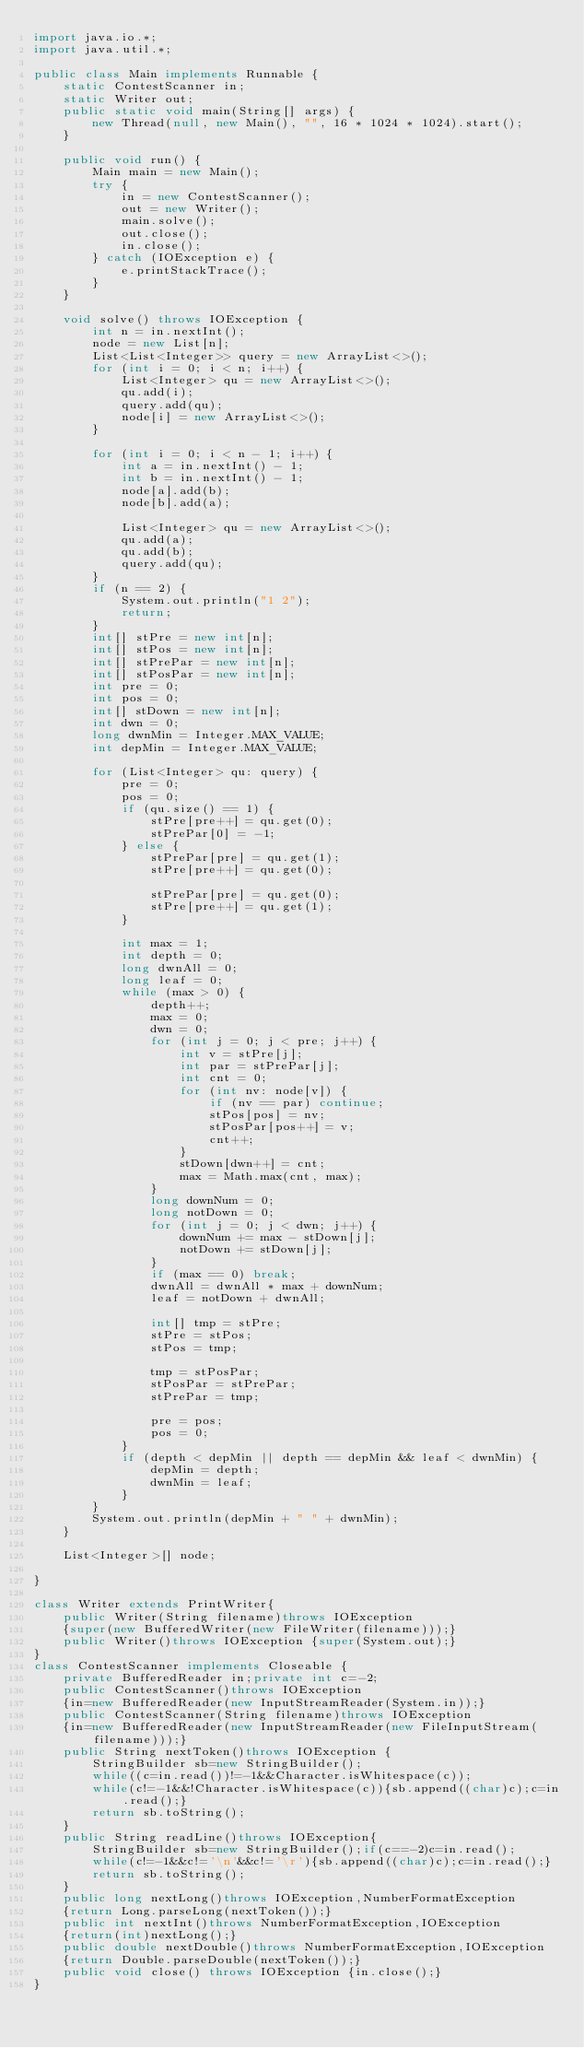Convert code to text. <code><loc_0><loc_0><loc_500><loc_500><_Java_>import java.io.*;
import java.util.*;

public class Main implements Runnable {
    static ContestScanner in;
    static Writer out;
    public static void main(String[] args) {
        new Thread(null, new Main(), "", 16 * 1024 * 1024).start();
    }

    public void run() {
        Main main = new Main();
        try {
            in = new ContestScanner();
            out = new Writer();
            main.solve();
            out.close();
            in.close();
        } catch (IOException e) {
            e.printStackTrace();
        }
    }

    void solve() throws IOException {
        int n = in.nextInt();
        node = new List[n];
        List<List<Integer>> query = new ArrayList<>();
        for (int i = 0; i < n; i++) {
            List<Integer> qu = new ArrayList<>();
            qu.add(i);
            query.add(qu);
            node[i] = new ArrayList<>();
        }

        for (int i = 0; i < n - 1; i++) {
            int a = in.nextInt() - 1;
            int b = in.nextInt() - 1;
            node[a].add(b);
            node[b].add(a);

            List<Integer> qu = new ArrayList<>();
            qu.add(a);
            qu.add(b);
            query.add(qu);
        }
        if (n == 2) {
            System.out.println("1 2");
            return;
        }
        int[] stPre = new int[n];
        int[] stPos = new int[n];
        int[] stPrePar = new int[n];
        int[] stPosPar = new int[n];
        int pre = 0;
        int pos = 0;
        int[] stDown = new int[n];
        int dwn = 0;
        long dwnMin = Integer.MAX_VALUE;
        int depMin = Integer.MAX_VALUE;

        for (List<Integer> qu: query) {
            pre = 0;
            pos = 0;
            if (qu.size() == 1) {
                stPre[pre++] = qu.get(0);
                stPrePar[0] = -1;
            } else {
                stPrePar[pre] = qu.get(1);
                stPre[pre++] = qu.get(0);

                stPrePar[pre] = qu.get(0);
                stPre[pre++] = qu.get(1);
            }

            int max = 1;
            int depth = 0;
            long dwnAll = 0;
            long leaf = 0;
            while (max > 0) {
                depth++;
                max = 0;
                dwn = 0;
                for (int j = 0; j < pre; j++) {
                    int v = stPre[j];
                    int par = stPrePar[j];
                    int cnt = 0;
                    for (int nv: node[v]) {
                        if (nv == par) continue;
                        stPos[pos] = nv;
                        stPosPar[pos++] = v;
                        cnt++;
                    }
                    stDown[dwn++] = cnt;
                    max = Math.max(cnt, max);
                }
                long downNum = 0;
                long notDown = 0;
                for (int j = 0; j < dwn; j++) {
                    downNum += max - stDown[j];
                    notDown += stDown[j];
                }
                if (max == 0) break;
                dwnAll = dwnAll * max + downNum;
                leaf = notDown + dwnAll;

                int[] tmp = stPre;
                stPre = stPos;
                stPos = tmp;

                tmp = stPosPar;
                stPosPar = stPrePar;
                stPrePar = tmp;

                pre = pos;
                pos = 0;
            }
            if (depth < depMin || depth == depMin && leaf < dwnMin) {
                depMin = depth;
                dwnMin = leaf;
            }
        }
        System.out.println(depMin + " " + dwnMin);
    }

    List<Integer>[] node;

}

class Writer extends PrintWriter{
    public Writer(String filename)throws IOException
    {super(new BufferedWriter(new FileWriter(filename)));}
    public Writer()throws IOException {super(System.out);}
}
class ContestScanner implements Closeable {
    private BufferedReader in;private int c=-2;
    public ContestScanner()throws IOException
    {in=new BufferedReader(new InputStreamReader(System.in));}
    public ContestScanner(String filename)throws IOException
    {in=new BufferedReader(new InputStreamReader(new FileInputStream(filename)));}
    public String nextToken()throws IOException {
        StringBuilder sb=new StringBuilder();
        while((c=in.read())!=-1&&Character.isWhitespace(c));
        while(c!=-1&&!Character.isWhitespace(c)){sb.append((char)c);c=in.read();}
        return sb.toString();
    }
    public String readLine()throws IOException{
        StringBuilder sb=new StringBuilder();if(c==-2)c=in.read();
        while(c!=-1&&c!='\n'&&c!='\r'){sb.append((char)c);c=in.read();}
        return sb.toString();
    }
    public long nextLong()throws IOException,NumberFormatException
    {return Long.parseLong(nextToken());}
    public int nextInt()throws NumberFormatException,IOException
    {return(int)nextLong();}
    public double nextDouble()throws NumberFormatException,IOException
    {return Double.parseDouble(nextToken());}
    public void close() throws IOException {in.close();}
}
</code> 